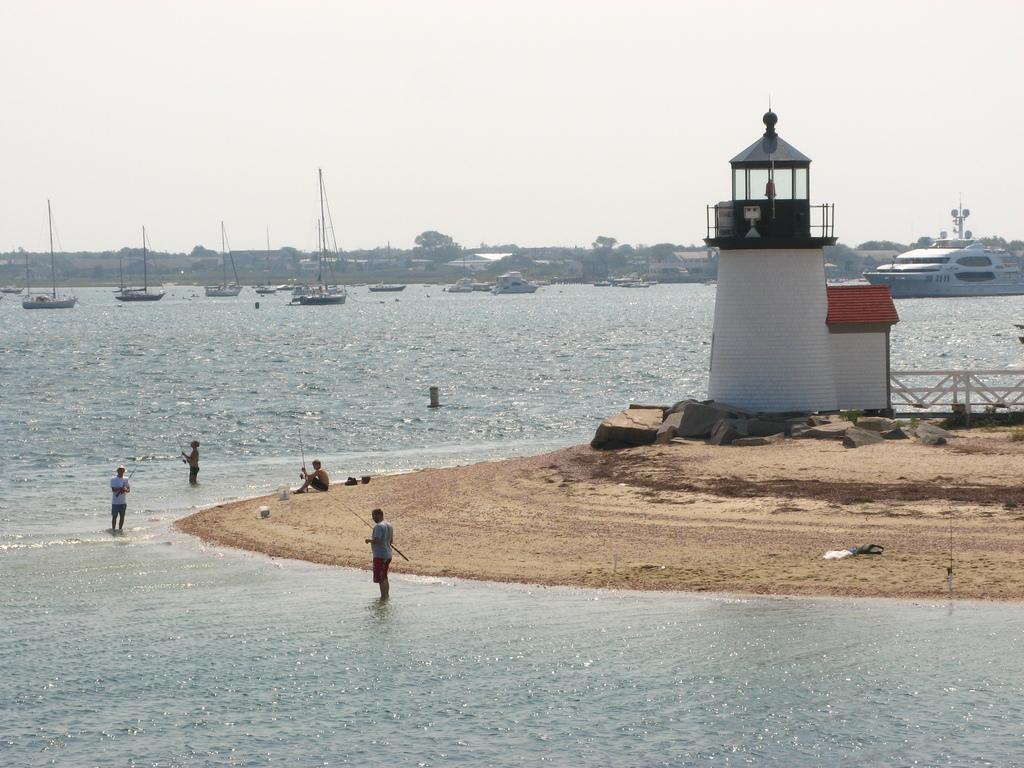In one or two sentences, can you explain what this image depicts? In this image, there are three persons standing in the water and a person sitting. On the right side of the image, I can see a lighthouse, rocks and fence. There are boats and a ship on the water. In the background, I can see trees and there is the sky. 